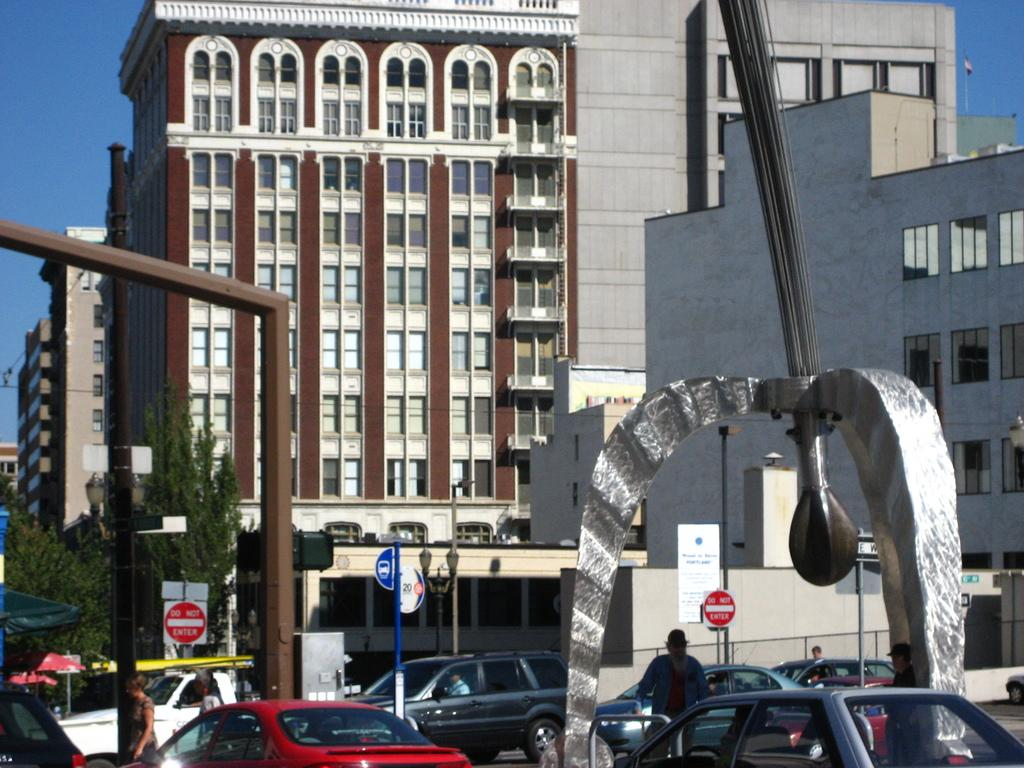What type of structures can be seen in the image? There are buildings in the image. What can be found on the road in the image? Cars are parked on the road in the image, and people are standing on the road as well. How many dogs are playing with the people on the road in the image? There are no dogs present in the image; only people and parked cars can be seen on the road. 